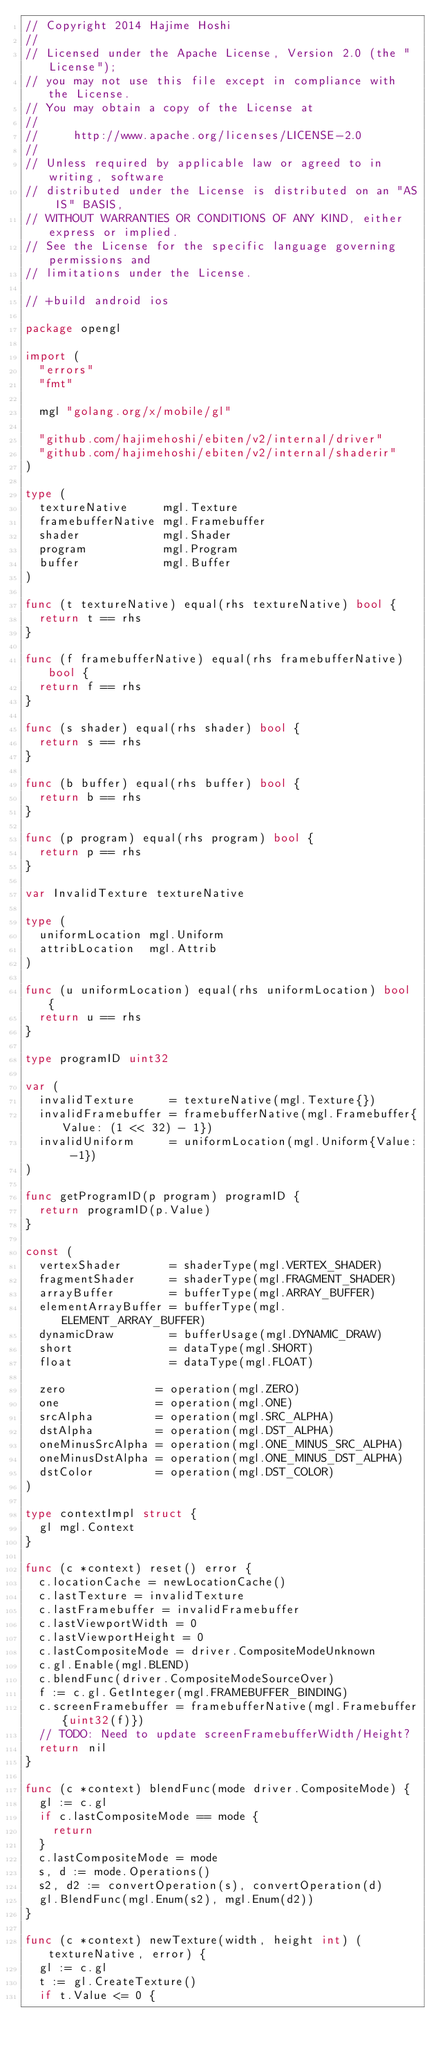Convert code to text. <code><loc_0><loc_0><loc_500><loc_500><_Go_>// Copyright 2014 Hajime Hoshi
//
// Licensed under the Apache License, Version 2.0 (the "License");
// you may not use this file except in compliance with the License.
// You may obtain a copy of the License at
//
//     http://www.apache.org/licenses/LICENSE-2.0
//
// Unless required by applicable law or agreed to in writing, software
// distributed under the License is distributed on an "AS IS" BASIS,
// WITHOUT WARRANTIES OR CONDITIONS OF ANY KIND, either express or implied.
// See the License for the specific language governing permissions and
// limitations under the License.

// +build android ios

package opengl

import (
	"errors"
	"fmt"

	mgl "golang.org/x/mobile/gl"

	"github.com/hajimehoshi/ebiten/v2/internal/driver"
	"github.com/hajimehoshi/ebiten/v2/internal/shaderir"
)

type (
	textureNative     mgl.Texture
	framebufferNative mgl.Framebuffer
	shader            mgl.Shader
	program           mgl.Program
	buffer            mgl.Buffer
)

func (t textureNative) equal(rhs textureNative) bool {
	return t == rhs
}

func (f framebufferNative) equal(rhs framebufferNative) bool {
	return f == rhs
}

func (s shader) equal(rhs shader) bool {
	return s == rhs
}

func (b buffer) equal(rhs buffer) bool {
	return b == rhs
}

func (p program) equal(rhs program) bool {
	return p == rhs
}

var InvalidTexture textureNative

type (
	uniformLocation mgl.Uniform
	attribLocation  mgl.Attrib
)

func (u uniformLocation) equal(rhs uniformLocation) bool {
	return u == rhs
}

type programID uint32

var (
	invalidTexture     = textureNative(mgl.Texture{})
	invalidFramebuffer = framebufferNative(mgl.Framebuffer{Value: (1 << 32) - 1})
	invalidUniform     = uniformLocation(mgl.Uniform{Value: -1})
)

func getProgramID(p program) programID {
	return programID(p.Value)
}

const (
	vertexShader       = shaderType(mgl.VERTEX_SHADER)
	fragmentShader     = shaderType(mgl.FRAGMENT_SHADER)
	arrayBuffer        = bufferType(mgl.ARRAY_BUFFER)
	elementArrayBuffer = bufferType(mgl.ELEMENT_ARRAY_BUFFER)
	dynamicDraw        = bufferUsage(mgl.DYNAMIC_DRAW)
	short              = dataType(mgl.SHORT)
	float              = dataType(mgl.FLOAT)

	zero             = operation(mgl.ZERO)
	one              = operation(mgl.ONE)
	srcAlpha         = operation(mgl.SRC_ALPHA)
	dstAlpha         = operation(mgl.DST_ALPHA)
	oneMinusSrcAlpha = operation(mgl.ONE_MINUS_SRC_ALPHA)
	oneMinusDstAlpha = operation(mgl.ONE_MINUS_DST_ALPHA)
	dstColor         = operation(mgl.DST_COLOR)
)

type contextImpl struct {
	gl mgl.Context
}

func (c *context) reset() error {
	c.locationCache = newLocationCache()
	c.lastTexture = invalidTexture
	c.lastFramebuffer = invalidFramebuffer
	c.lastViewportWidth = 0
	c.lastViewportHeight = 0
	c.lastCompositeMode = driver.CompositeModeUnknown
	c.gl.Enable(mgl.BLEND)
	c.blendFunc(driver.CompositeModeSourceOver)
	f := c.gl.GetInteger(mgl.FRAMEBUFFER_BINDING)
	c.screenFramebuffer = framebufferNative(mgl.Framebuffer{uint32(f)})
	// TODO: Need to update screenFramebufferWidth/Height?
	return nil
}

func (c *context) blendFunc(mode driver.CompositeMode) {
	gl := c.gl
	if c.lastCompositeMode == mode {
		return
	}
	c.lastCompositeMode = mode
	s, d := mode.Operations()
	s2, d2 := convertOperation(s), convertOperation(d)
	gl.BlendFunc(mgl.Enum(s2), mgl.Enum(d2))
}

func (c *context) newTexture(width, height int) (textureNative, error) {
	gl := c.gl
	t := gl.CreateTexture()
	if t.Value <= 0 {</code> 